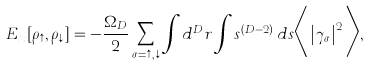<formula> <loc_0><loc_0><loc_500><loc_500>E _ { x } [ \rho _ { \uparrow } , \rho _ { \downarrow } ] = - \frac { \Omega _ { D } } { 2 } \sum _ { \sigma = \uparrow , \downarrow } \int d ^ { D } r \int s ^ { ( D - 2 ) } \, d s \Big < \left | \gamma _ { \sigma } \right | ^ { 2 } \Big > ,</formula> 